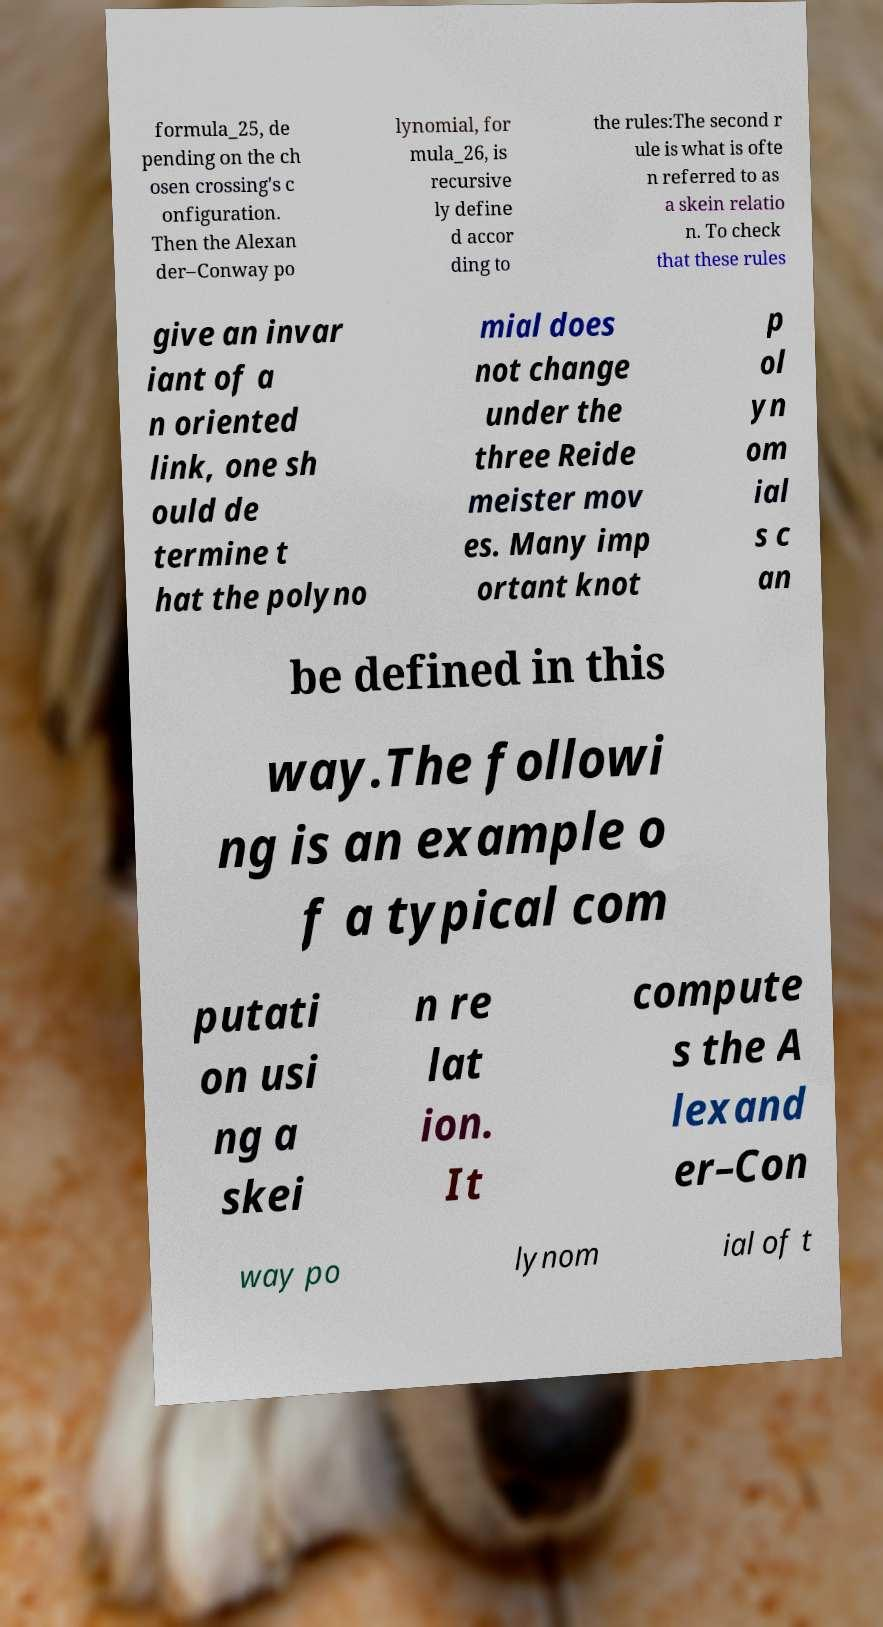Please identify and transcribe the text found in this image. formula_25, de pending on the ch osen crossing's c onfiguration. Then the Alexan der–Conway po lynomial, for mula_26, is recursive ly define d accor ding to the rules:The second r ule is what is ofte n referred to as a skein relatio n. To check that these rules give an invar iant of a n oriented link, one sh ould de termine t hat the polyno mial does not change under the three Reide meister mov es. Many imp ortant knot p ol yn om ial s c an be defined in this way.The followi ng is an example o f a typical com putati on usi ng a skei n re lat ion. It compute s the A lexand er–Con way po lynom ial of t 